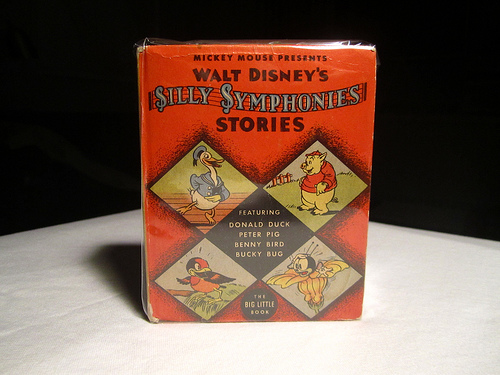<image>
Is the book next to the table? No. The book is not positioned next to the table. They are located in different areas of the scene. 